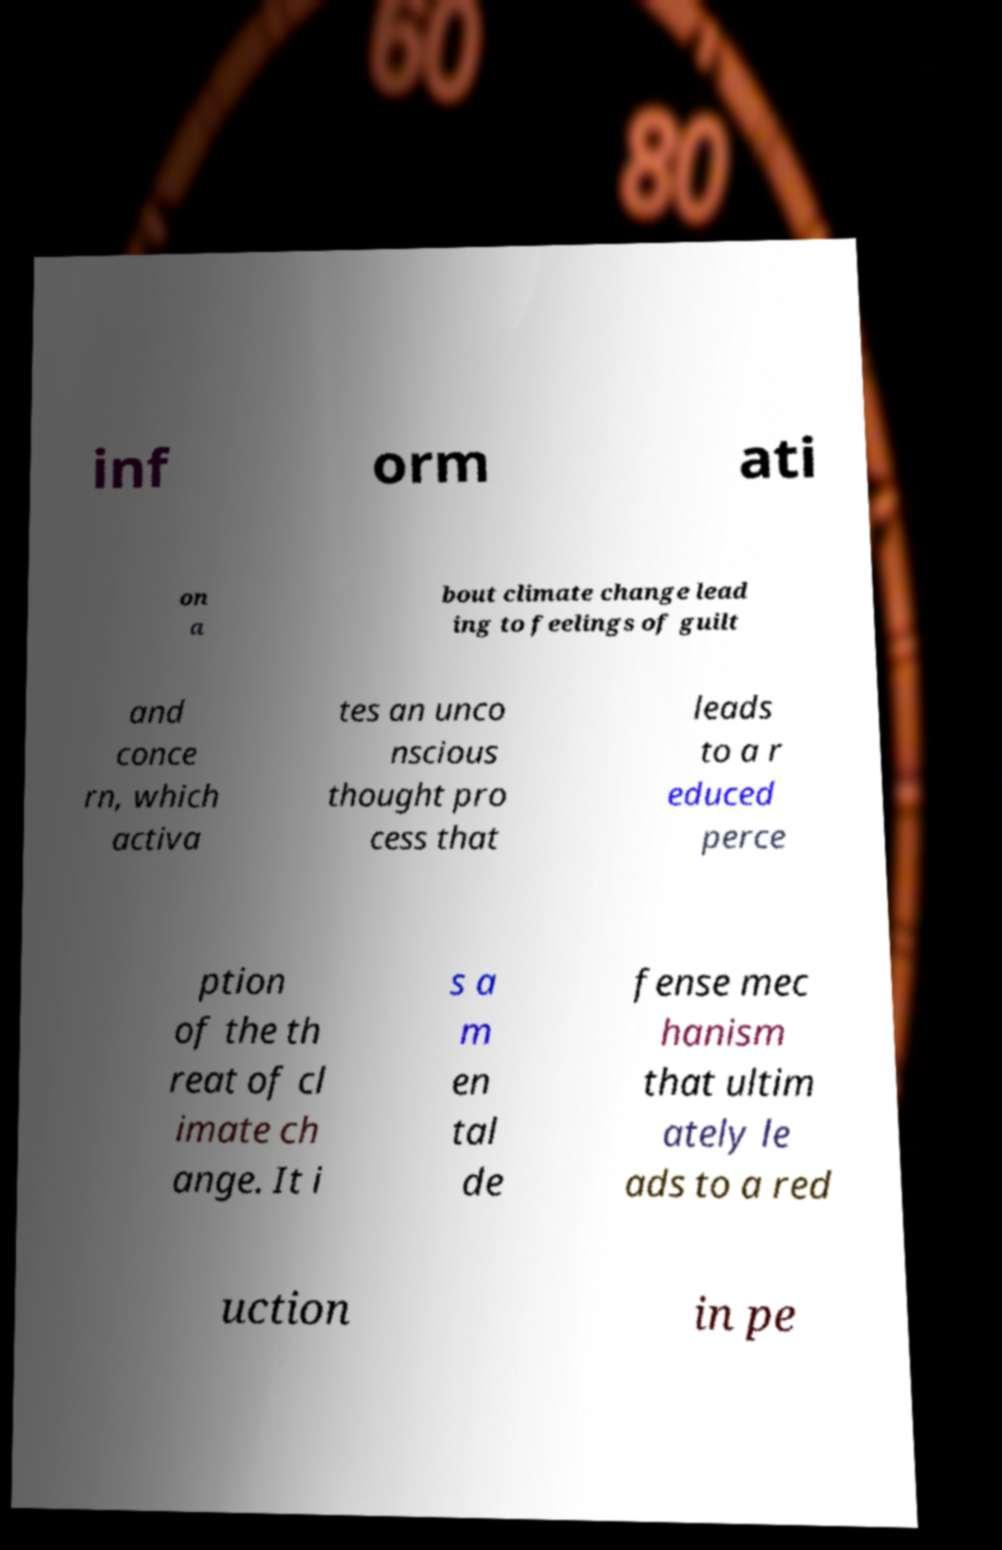For documentation purposes, I need the text within this image transcribed. Could you provide that? inf orm ati on a bout climate change lead ing to feelings of guilt and conce rn, which activa tes an unco nscious thought pro cess that leads to a r educed perce ption of the th reat of cl imate ch ange. It i s a m en tal de fense mec hanism that ultim ately le ads to a red uction in pe 